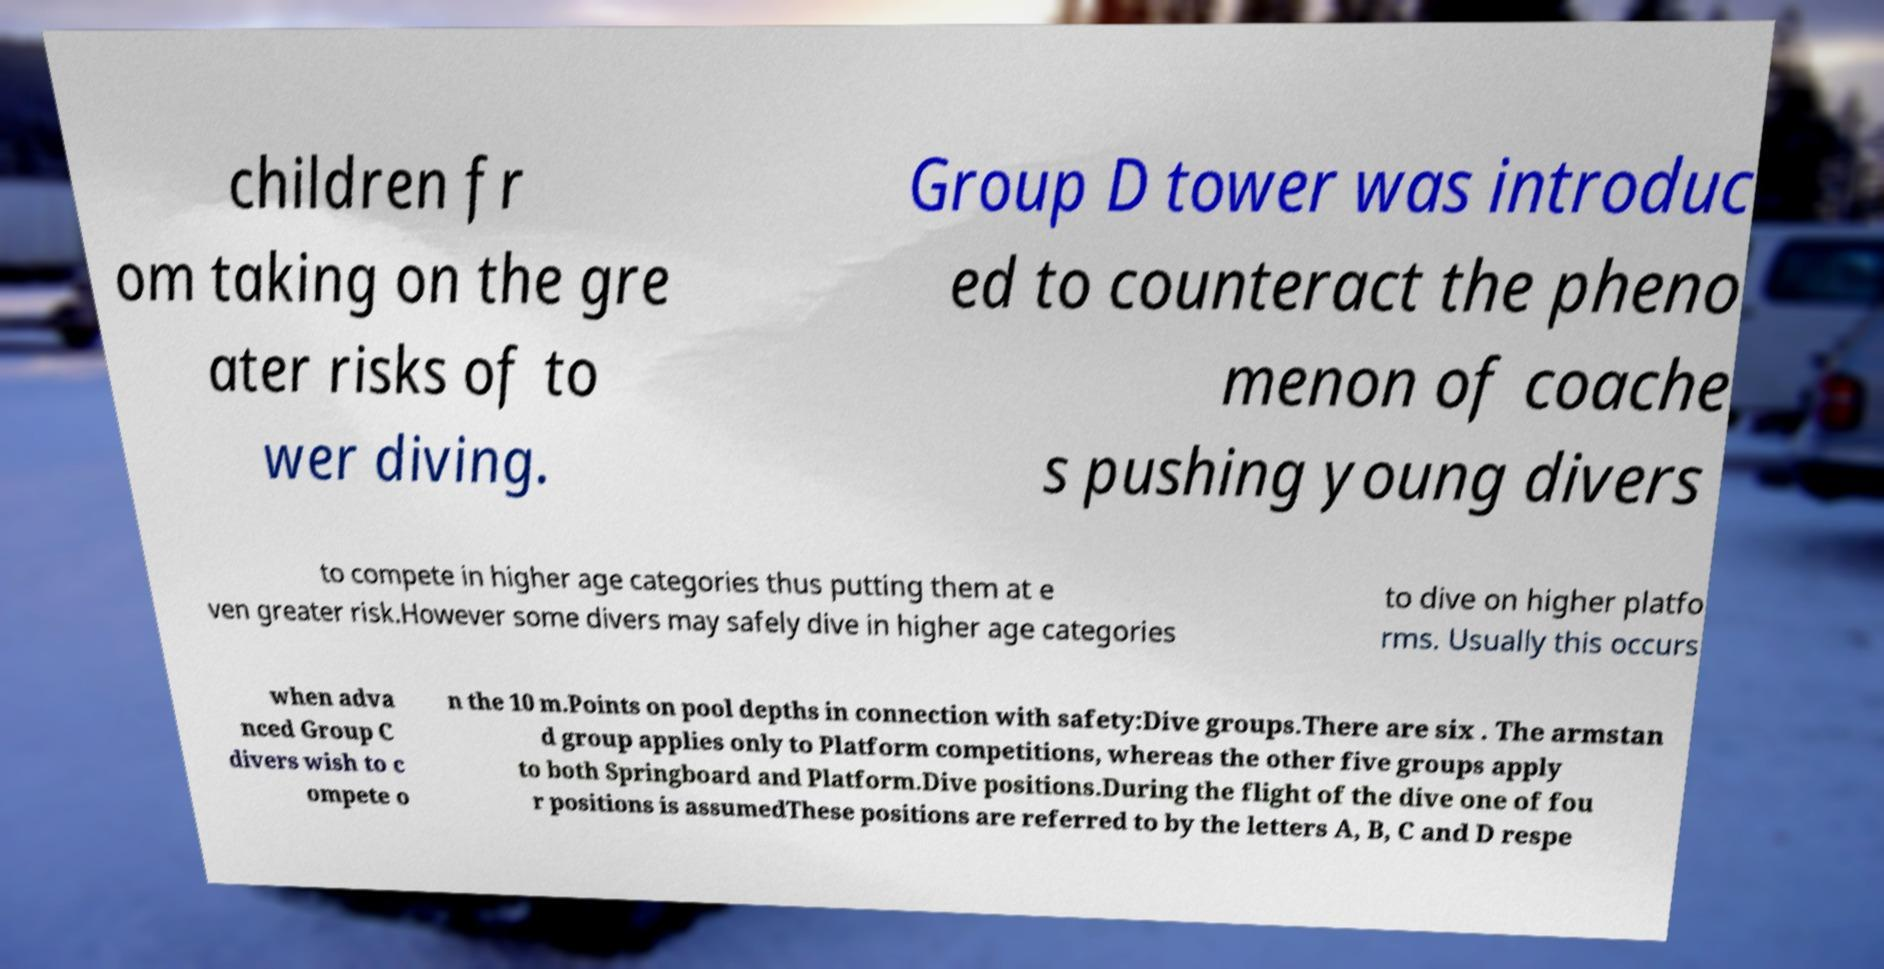Could you assist in decoding the text presented in this image and type it out clearly? children fr om taking on the gre ater risks of to wer diving. Group D tower was introduc ed to counteract the pheno menon of coache s pushing young divers to compete in higher age categories thus putting them at e ven greater risk.However some divers may safely dive in higher age categories to dive on higher platfo rms. Usually this occurs when adva nced Group C divers wish to c ompete o n the 10 m.Points on pool depths in connection with safety:Dive groups.There are six . The armstan d group applies only to Platform competitions, whereas the other five groups apply to both Springboard and Platform.Dive positions.During the flight of the dive one of fou r positions is assumedThese positions are referred to by the letters A, B, C and D respe 